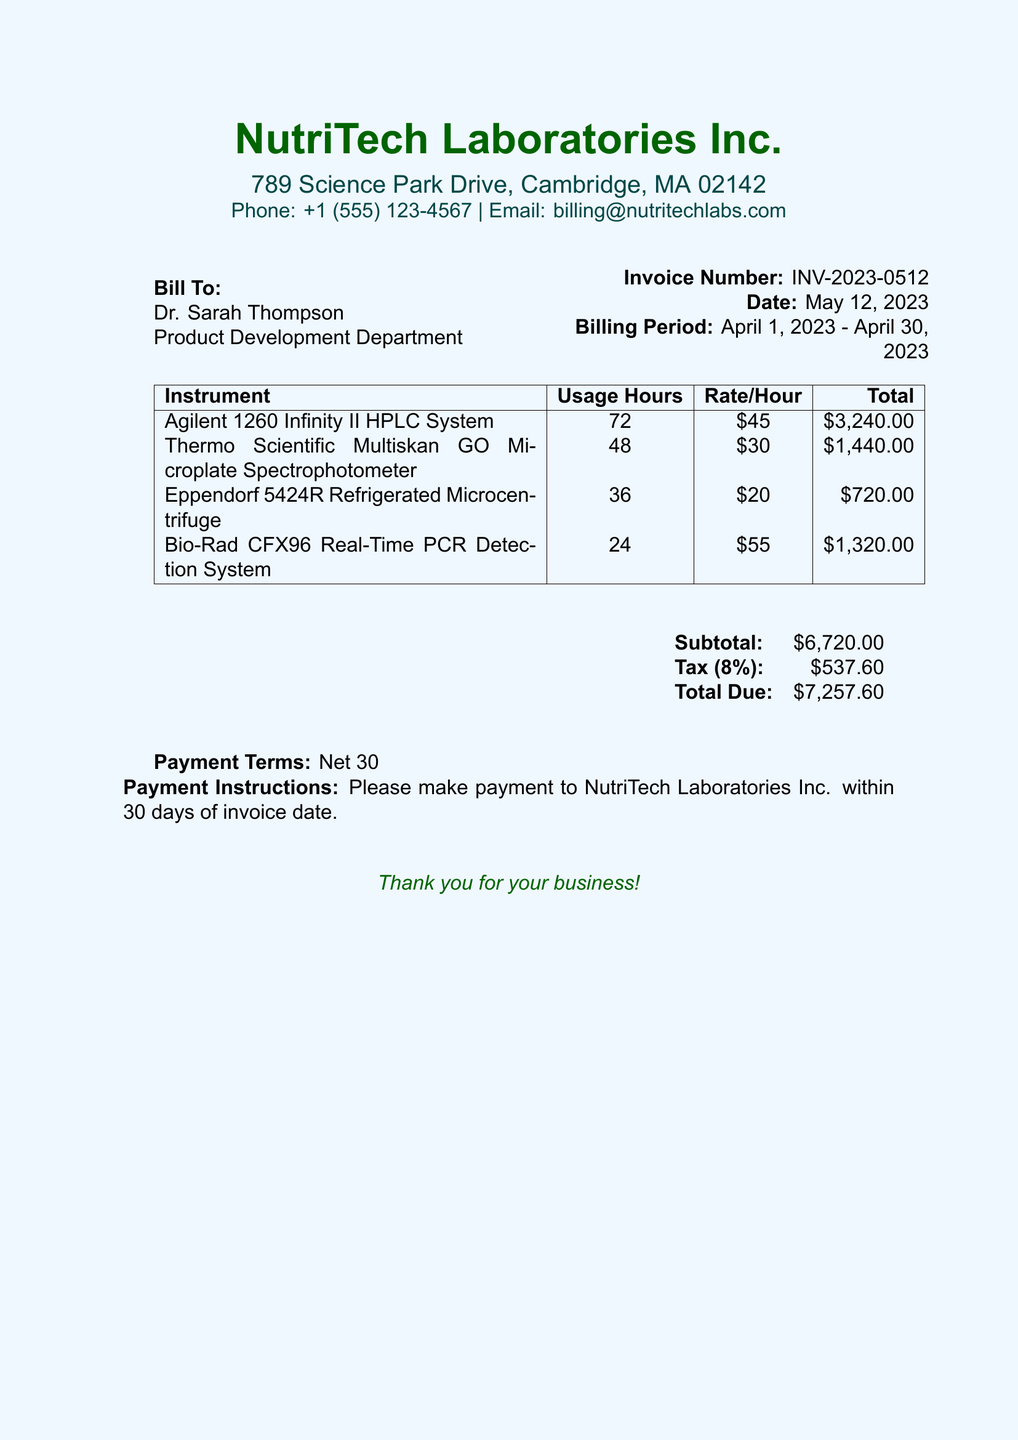What is the invoice number? The invoice number is specified in the top right corner of the document.
Answer: INV-2023-0512 What is the billing period? The billing period is indicated next to the invoice date.
Answer: April 1, 2023 - April 30, 2023 What is the total due amount? The total due amount is found in the summary table of the document.
Answer: $7,257.60 How many hours was the Agilent HPLC System used? The usage hours for the Agilent HPLC System are listed in the itemized section.
Answer: 72 What is the tax percentage applied? The tax percentage is noted in the summary section of the bill.
Answer: 8% Which instrument has the highest usage hours? Comparing the usage hours listed, we can identify which instrument was used the most.
Answer: Agilent 1260 Infinity II HPLC System What is the rate per hour for the Thermo Scientific Multiskan GO? The rate per hour for this specific instrument is detailed in the itemized list.
Answer: $30 What are the payment terms stated in the document? The payment terms are provided at the bottom of the invoice.
Answer: Net 30 What is the subtotal amount before tax? The subtotal amount is the total of all instruments listed before tax is added.
Answer: $6,720.00 